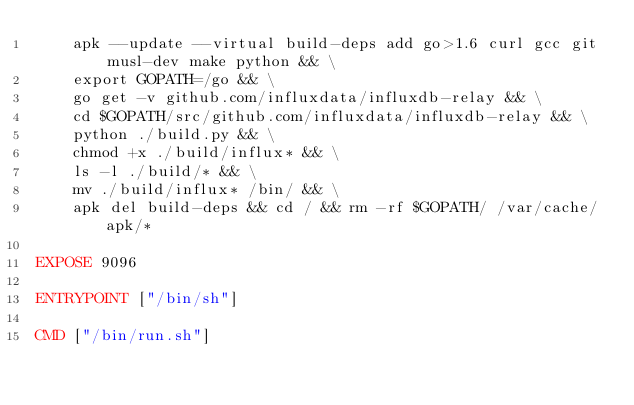Convert code to text. <code><loc_0><loc_0><loc_500><loc_500><_Dockerfile_>    apk --update --virtual build-deps add go>1.6 curl gcc git musl-dev make python && \
    export GOPATH=/go && \
    go get -v github.com/influxdata/influxdb-relay && \
    cd $GOPATH/src/github.com/influxdata/influxdb-relay && \
    python ./build.py && \
    chmod +x ./build/influx* && \
    ls -l ./build/* && \
    mv ./build/influx* /bin/ && \
    apk del build-deps && cd / && rm -rf $GOPATH/ /var/cache/apk/*

EXPOSE 9096

ENTRYPOINT ["/bin/sh"]

CMD ["/bin/run.sh"]
</code> 